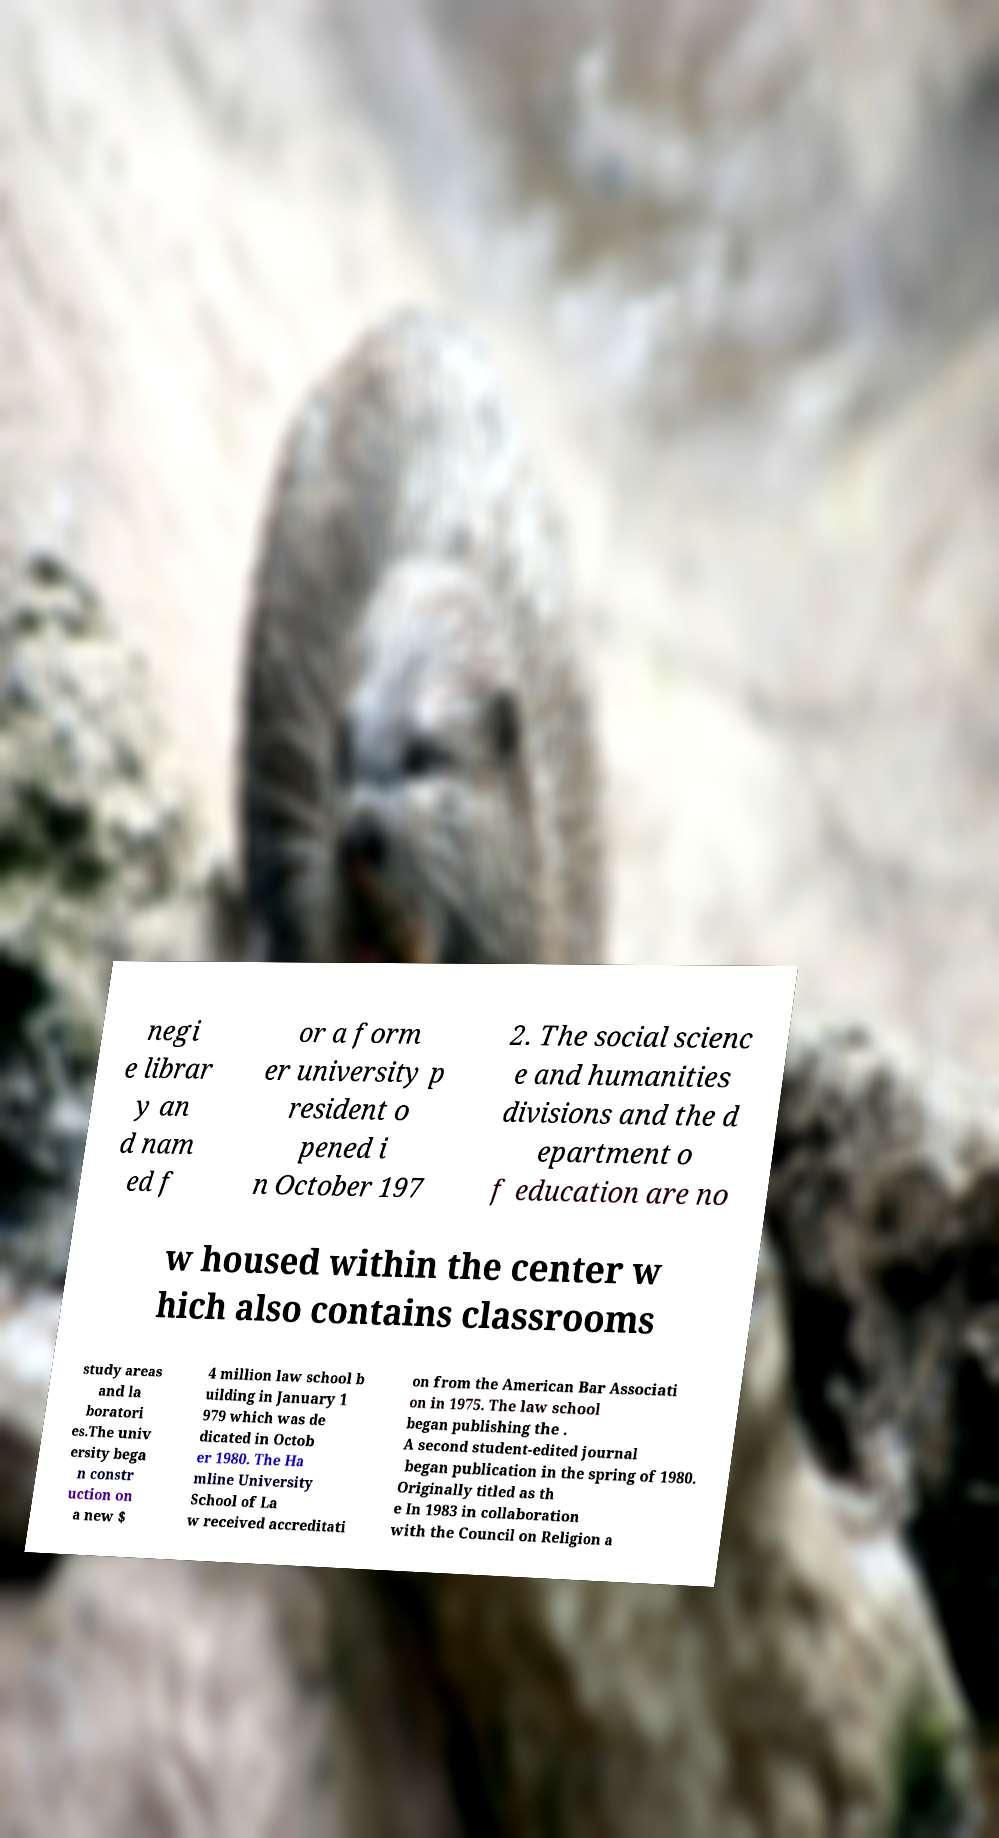Could you assist in decoding the text presented in this image and type it out clearly? negi e librar y an d nam ed f or a form er university p resident o pened i n October 197 2. The social scienc e and humanities divisions and the d epartment o f education are no w housed within the center w hich also contains classrooms study areas and la boratori es.The univ ersity bega n constr uction on a new $ 4 million law school b uilding in January 1 979 which was de dicated in Octob er 1980. The Ha mline University School of La w received accreditati on from the American Bar Associati on in 1975. The law school began publishing the . A second student-edited journal began publication in the spring of 1980. Originally titled as th e In 1983 in collaboration with the Council on Religion a 